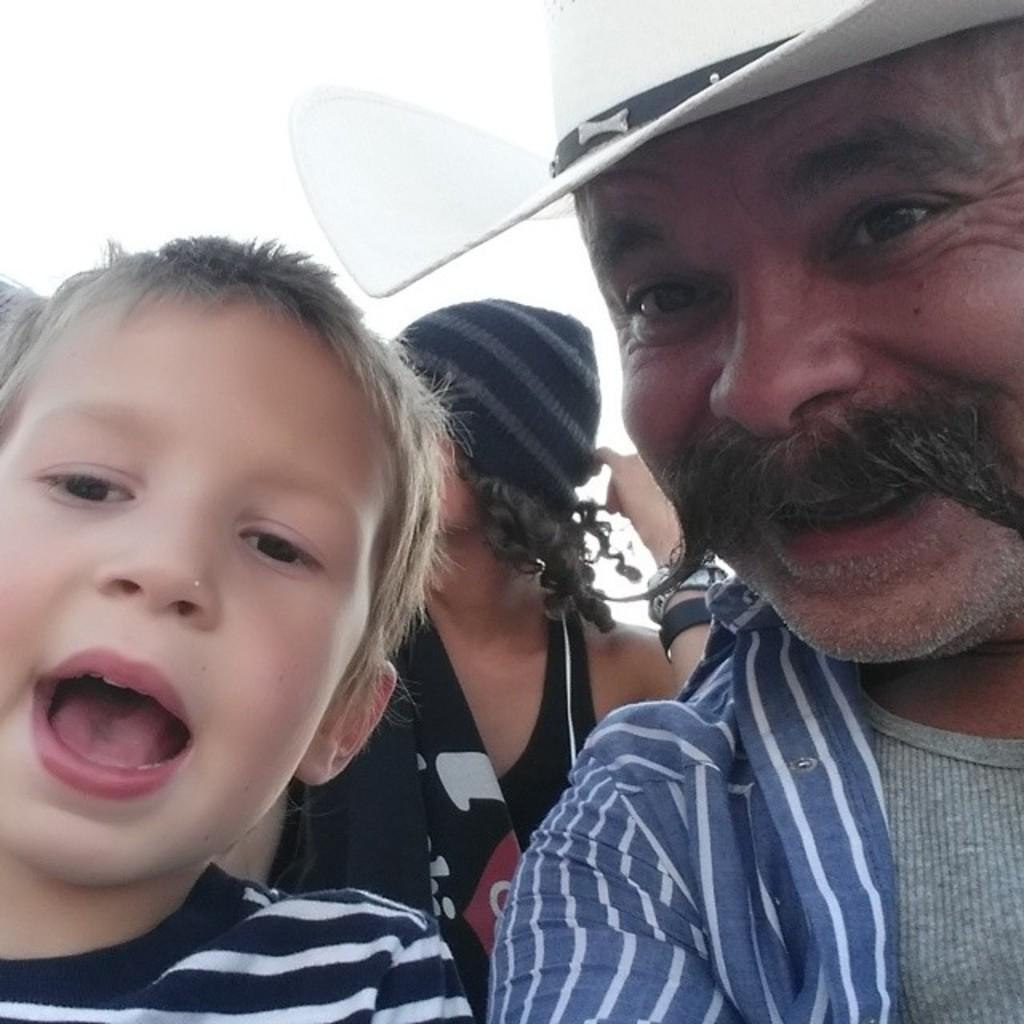What is the man in the image wearing? The man is wearing a grey shirt and a white hat. What is the man's facial expression in the image? The man is smiling. Who is beside the man in the image? There is a boy beside the man in the image. What is the boy wearing? The boy is wearing a black and white striped t-shirt. What is the boy's facial expression in the image? The boy is smiling. What can be seen in the background of the image? There are people visible in the background of the image. What part of the natural environment is visible in the image? The sky is visible in the image. Can you point out the zipper on the man's shirt in the image? There is no zipper present on the man's shirt in the image. 